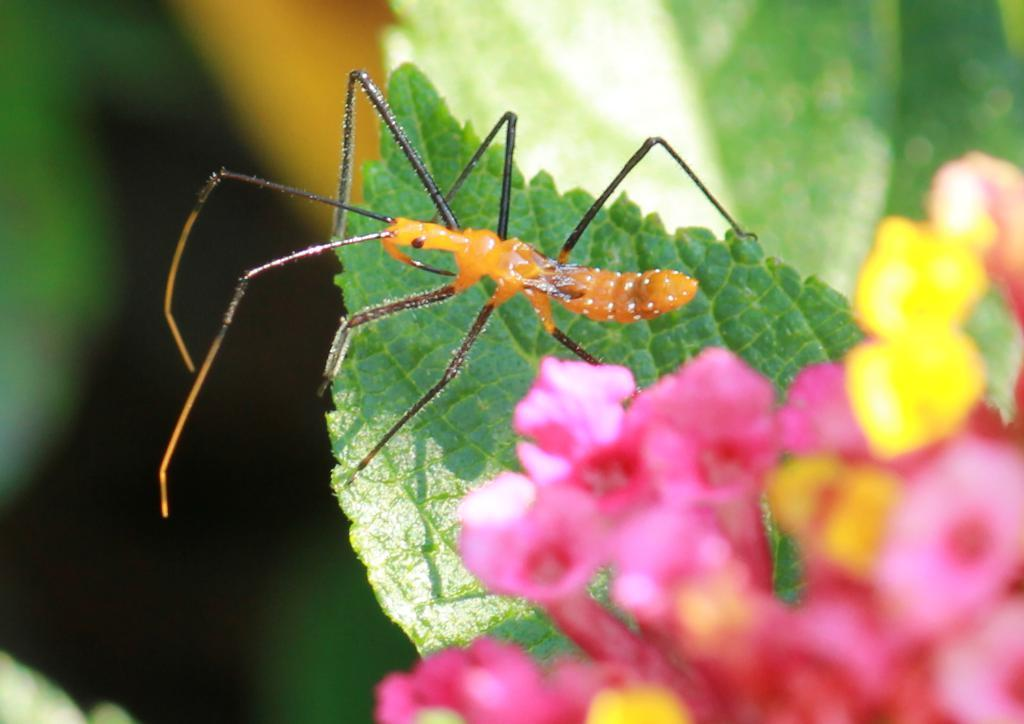What type of living organisms can be seen in the image? There are flowers and an insect in the image. Can you describe the insect's location in the image? The insect is on a leaf in the image. What can be observed about the background of the image? The background of the image is blurred. What type of care can be seen being provided to the alley in the image? There is no alley present in the image, and therefore no care can be observed being provided to it. 